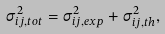<formula> <loc_0><loc_0><loc_500><loc_500>\sigma ^ { 2 } _ { i j , t o t } = \sigma ^ { 2 } _ { i j , e x p } + \sigma ^ { 2 } _ { i j , t h } ,</formula> 